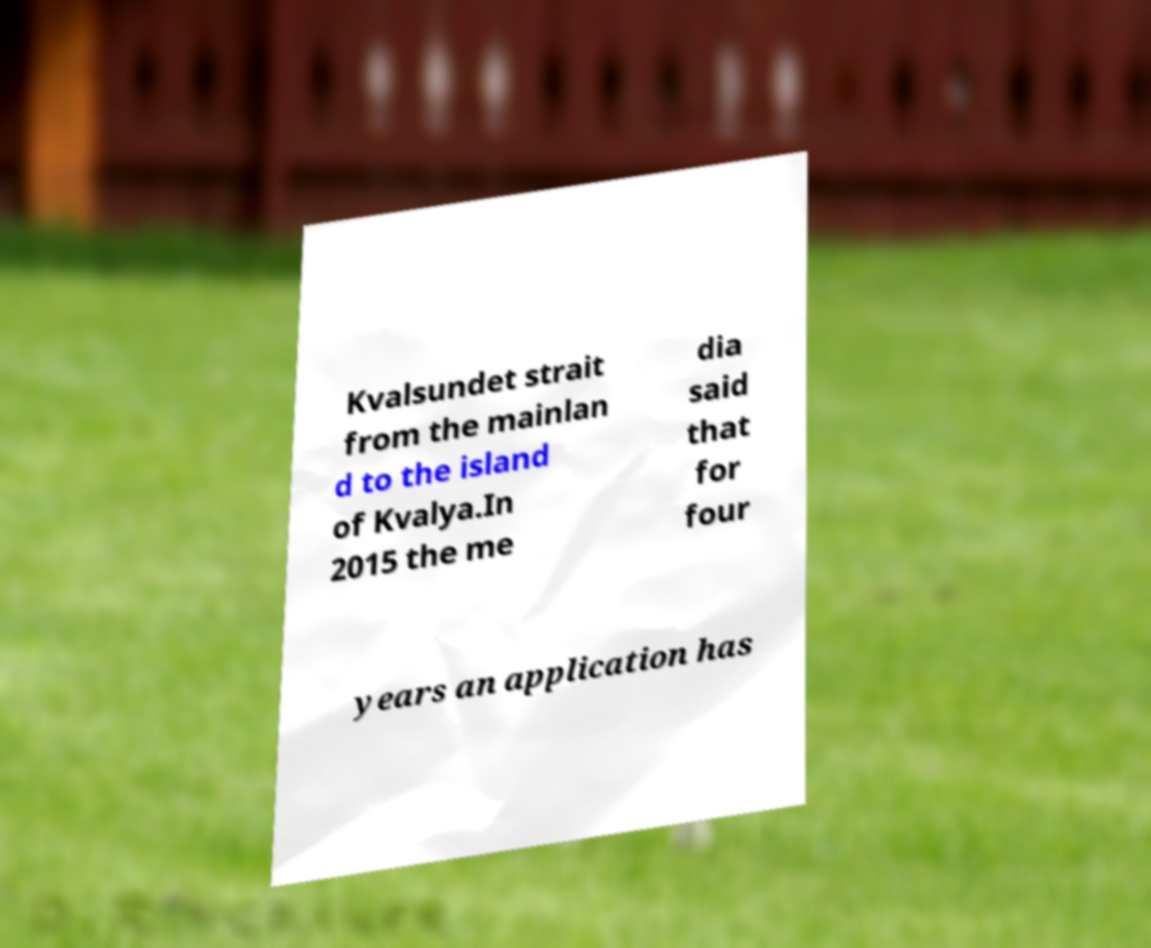For documentation purposes, I need the text within this image transcribed. Could you provide that? Kvalsundet strait from the mainlan d to the island of Kvalya.In 2015 the me dia said that for four years an application has 